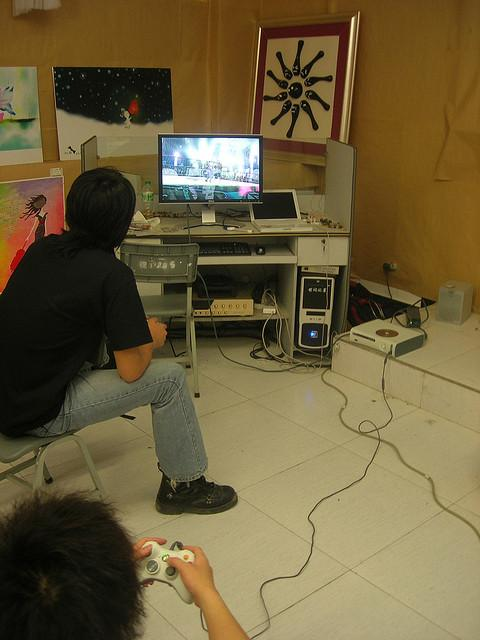What are the people playing? Please explain your reasoning. video games. Two people are playing a competitive game using a controller. 